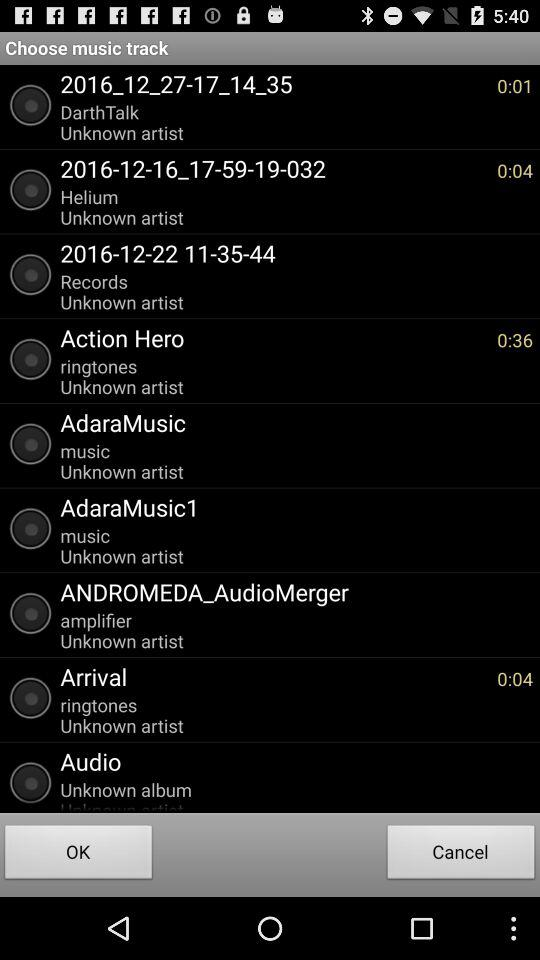What is the duration of the "Action Hero" music track? The duration is 36 seconds. 